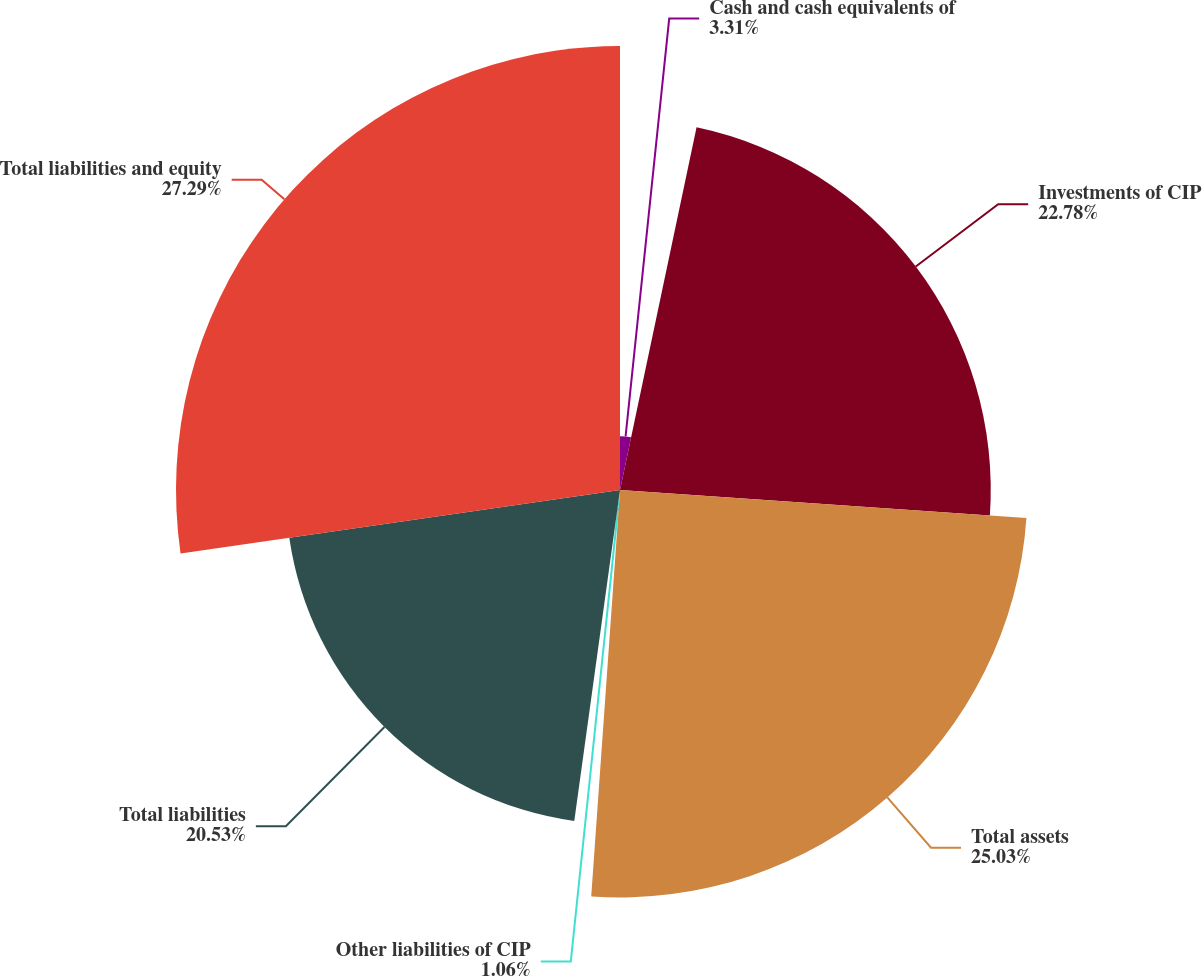<chart> <loc_0><loc_0><loc_500><loc_500><pie_chart><fcel>Cash and cash equivalents of<fcel>Investments of CIP<fcel>Total assets<fcel>Other liabilities of CIP<fcel>Total liabilities<fcel>Total liabilities and equity<nl><fcel>3.31%<fcel>22.78%<fcel>25.03%<fcel>1.06%<fcel>20.53%<fcel>27.28%<nl></chart> 